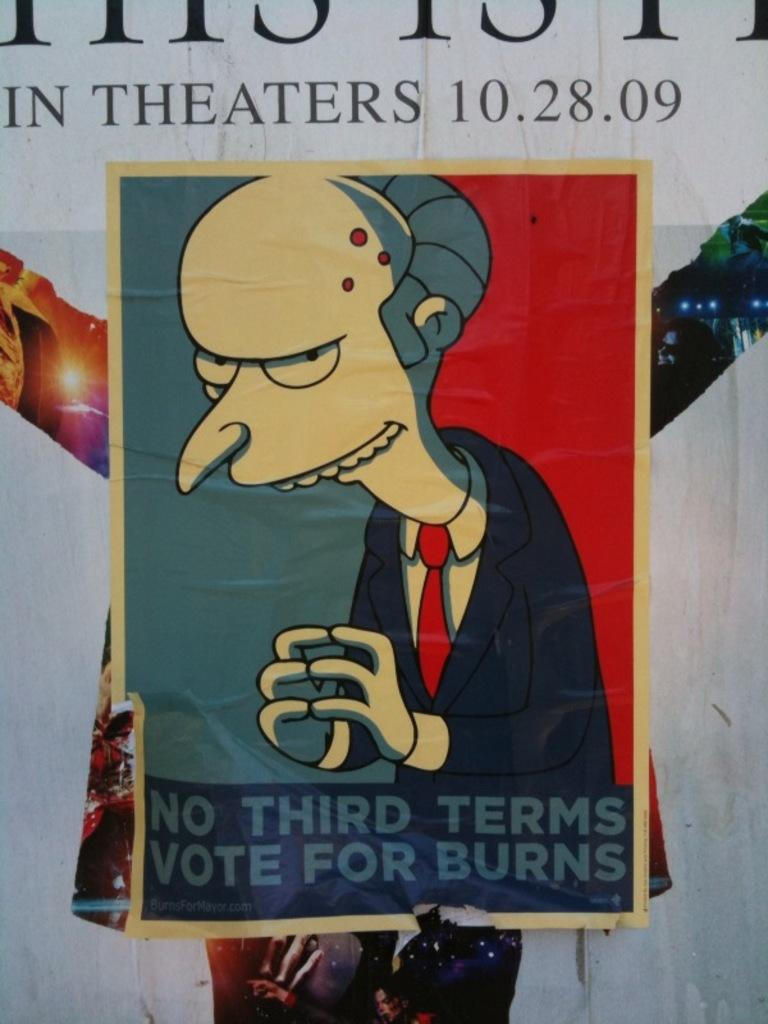What type of poster is in the image? There is an anime poster in the image. Where is the poster located? The poster is on a wall. What else can be seen on the poster besides the anime image? There is text on the poster. What type of connection is required to charge the oranges in the image? There are no oranges present in the image, and therefore no such charging activity can be observed. What advice might the dad in the image give to his child? There is no dad or child present in the image, so it is not possible to determine what advice might be given. 